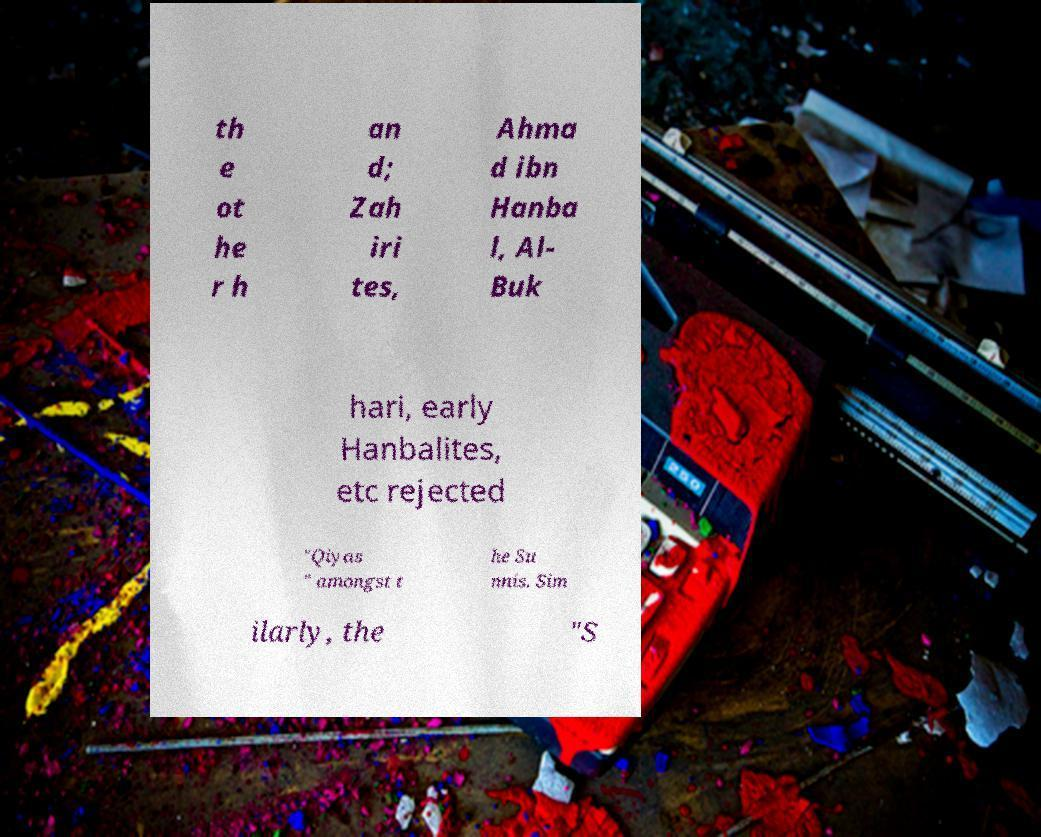Can you accurately transcribe the text from the provided image for me? th e ot he r h an d; Zah iri tes, Ahma d ibn Hanba l, Al- Buk hari, early Hanbalites, etc rejected "Qiyas " amongst t he Su nnis. Sim ilarly, the "S 